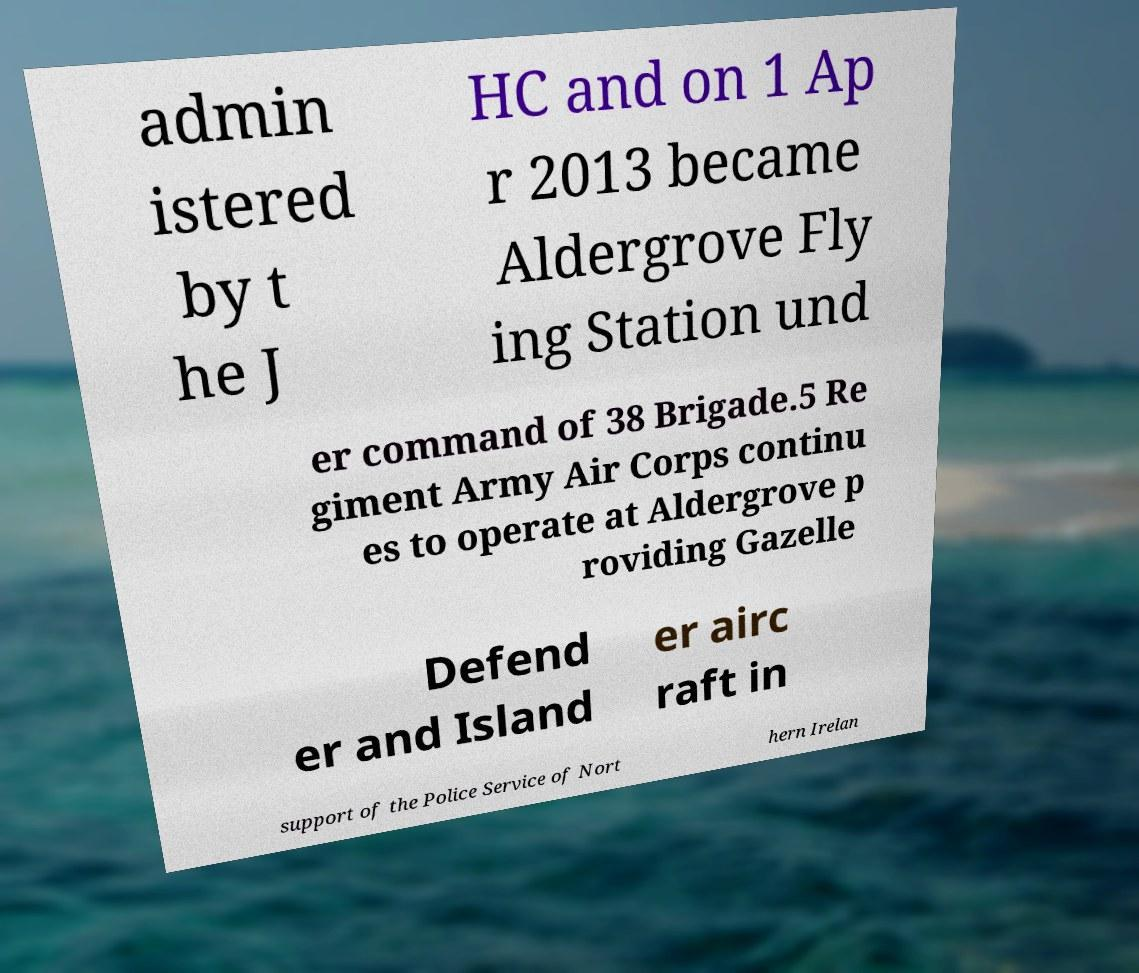For documentation purposes, I need the text within this image transcribed. Could you provide that? admin istered by t he J HC and on 1 Ap r 2013 became Aldergrove Fly ing Station und er command of 38 Brigade.5 Re giment Army Air Corps continu es to operate at Aldergrove p roviding Gazelle Defend er and Island er airc raft in support of the Police Service of Nort hern Irelan 